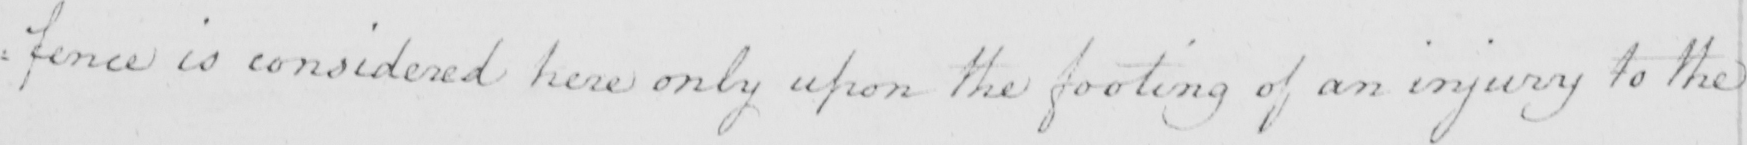Please transcribe the handwritten text in this image. : fence is considered here only upon the footing of an injury to the 